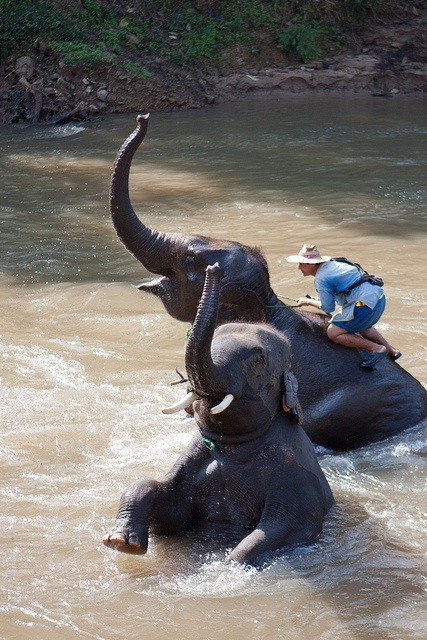Describe the objects in this image and their specific colors. I can see elephant in darkgreen, black, gray, and darkgray tones, elephant in darkgreen, black, gray, and tan tones, people in darkgreen, navy, black, white, and gray tones, and backpack in darkgreen, black, gray, navy, and darkgray tones in this image. 